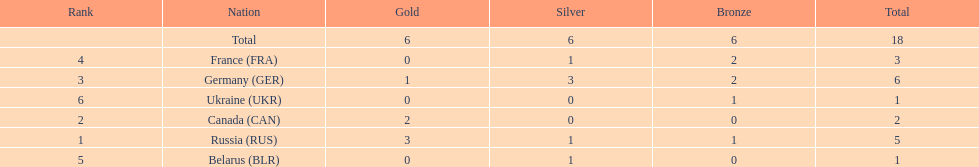What country had the most medals total at the the 1994 winter olympics biathlon? Germany (GER). 